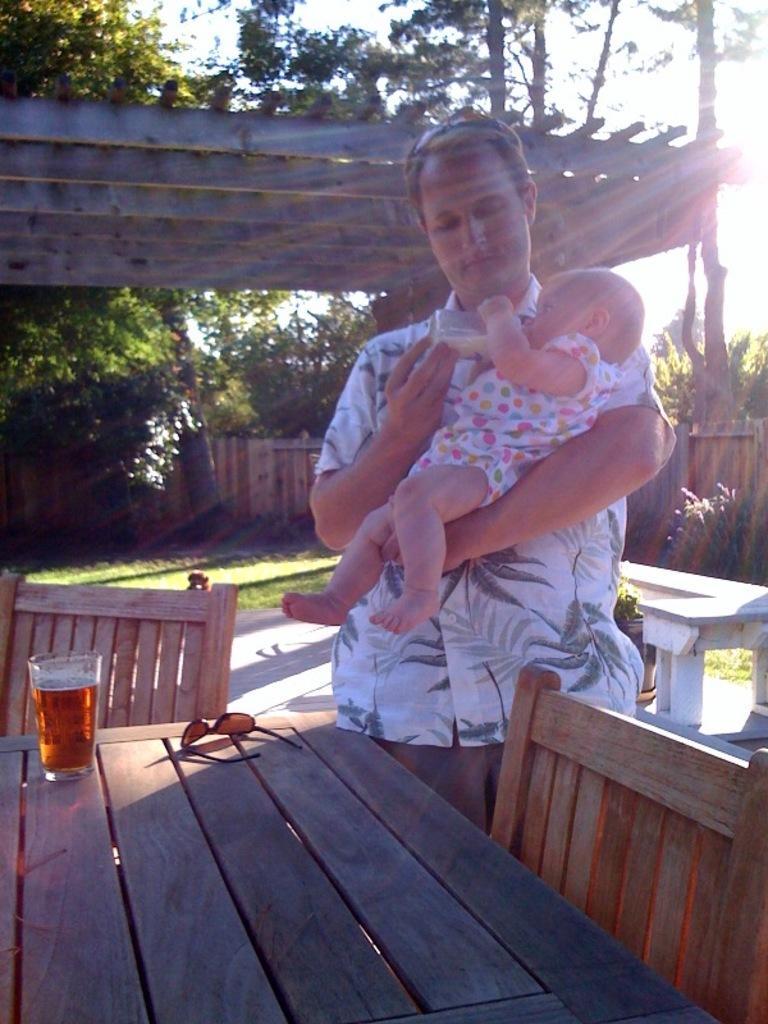Please provide a concise description of this image. In this picture we can see a man holding bottle with his hand and a baby with other hand and in front of him we can see chairs, table and on table glass with drink in it, goggle and in the background we can see tree, shed, wall, sky. 